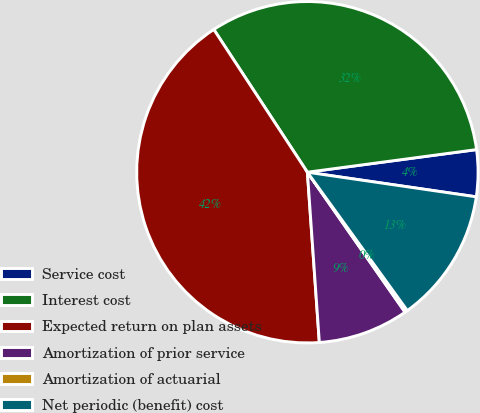Convert chart. <chart><loc_0><loc_0><loc_500><loc_500><pie_chart><fcel>Service cost<fcel>Interest cost<fcel>Expected return on plan assets<fcel>Amortization of prior service<fcel>Amortization of actuarial<fcel>Net periodic (benefit) cost<nl><fcel>4.42%<fcel>32.12%<fcel>41.88%<fcel>8.58%<fcel>0.26%<fcel>12.74%<nl></chart> 